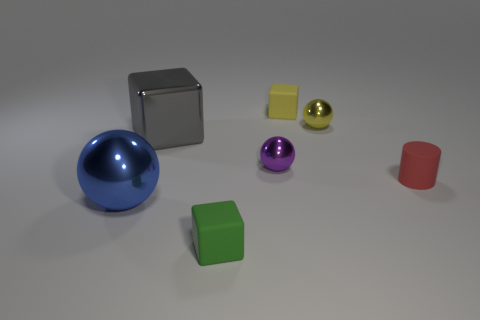Add 1 small yellow cubes. How many objects exist? 8 Subtract all blocks. How many objects are left? 4 Subtract all small cylinders. Subtract all cubes. How many objects are left? 3 Add 7 large blocks. How many large blocks are left? 8 Add 1 blocks. How many blocks exist? 4 Subtract 1 red cylinders. How many objects are left? 6 